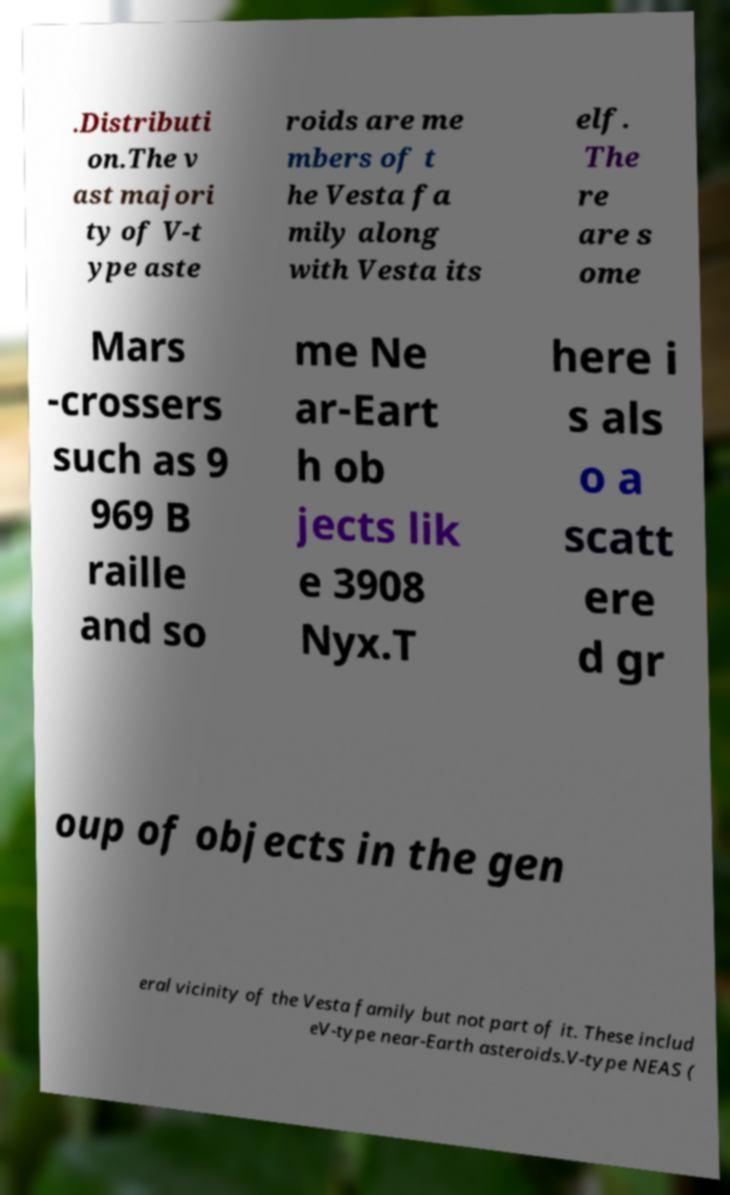What messages or text are displayed in this image? I need them in a readable, typed format. .Distributi on.The v ast majori ty of V-t ype aste roids are me mbers of t he Vesta fa mily along with Vesta its elf. The re are s ome Mars -crossers such as 9 969 B raille and so me Ne ar-Eart h ob jects lik e 3908 Nyx.T here i s als o a scatt ere d gr oup of objects in the gen eral vicinity of the Vesta family but not part of it. These includ eV-type near-Earth asteroids.V-type NEAS ( 